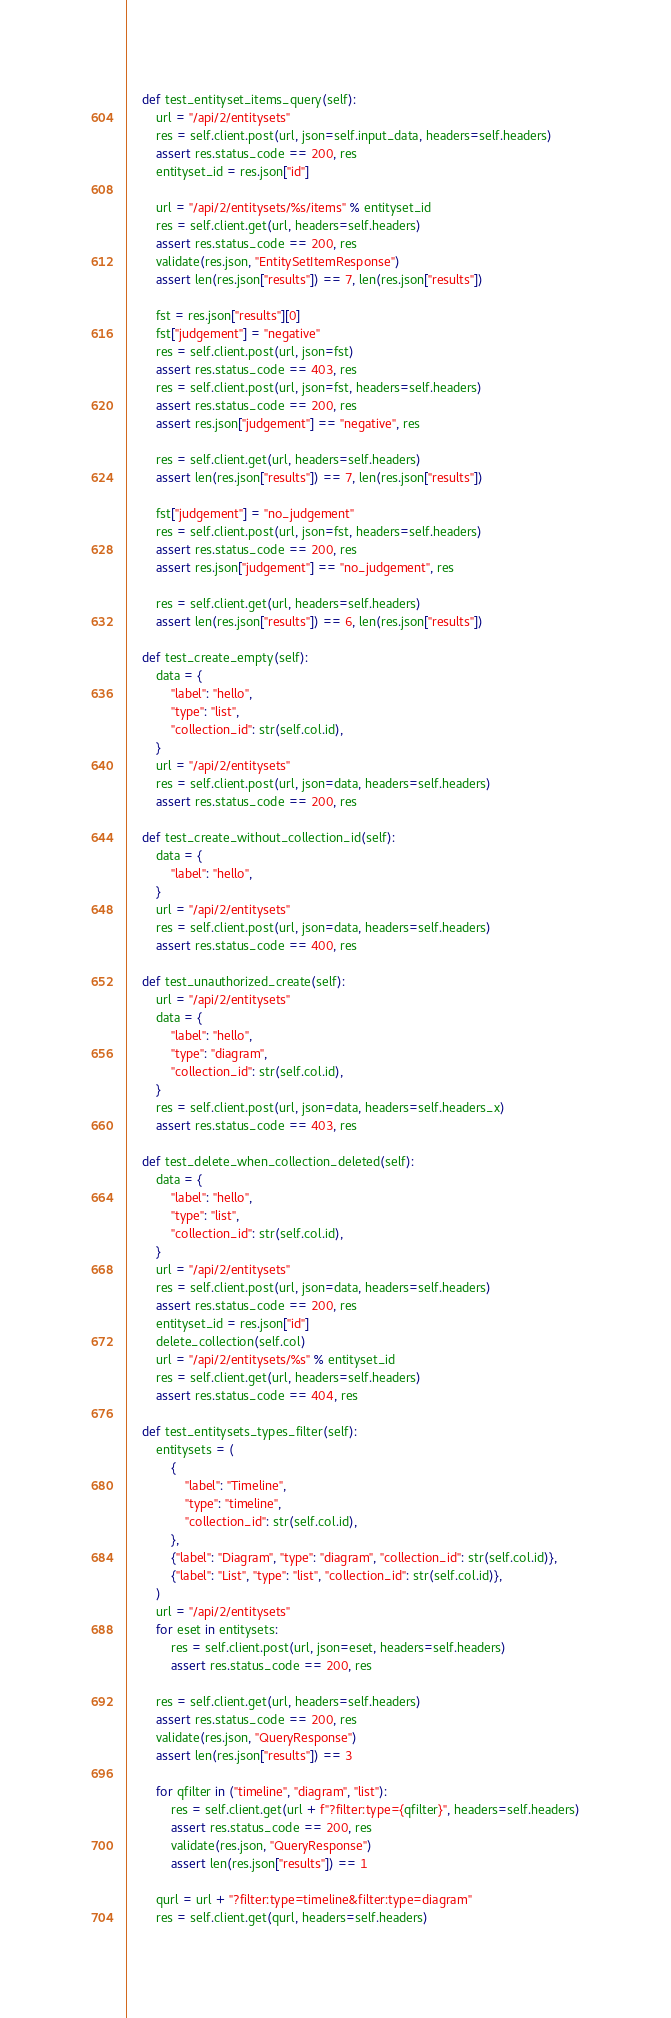<code> <loc_0><loc_0><loc_500><loc_500><_Python_>    def test_entityset_items_query(self):
        url = "/api/2/entitysets"
        res = self.client.post(url, json=self.input_data, headers=self.headers)
        assert res.status_code == 200, res
        entityset_id = res.json["id"]

        url = "/api/2/entitysets/%s/items" % entityset_id
        res = self.client.get(url, headers=self.headers)
        assert res.status_code == 200, res
        validate(res.json, "EntitySetItemResponse")
        assert len(res.json["results"]) == 7, len(res.json["results"])

        fst = res.json["results"][0]
        fst["judgement"] = "negative"
        res = self.client.post(url, json=fst)
        assert res.status_code == 403, res
        res = self.client.post(url, json=fst, headers=self.headers)
        assert res.status_code == 200, res
        assert res.json["judgement"] == "negative", res

        res = self.client.get(url, headers=self.headers)
        assert len(res.json["results"]) == 7, len(res.json["results"])

        fst["judgement"] = "no_judgement"
        res = self.client.post(url, json=fst, headers=self.headers)
        assert res.status_code == 200, res
        assert res.json["judgement"] == "no_judgement", res

        res = self.client.get(url, headers=self.headers)
        assert len(res.json["results"]) == 6, len(res.json["results"])

    def test_create_empty(self):
        data = {
            "label": "hello",
            "type": "list",
            "collection_id": str(self.col.id),
        }
        url = "/api/2/entitysets"
        res = self.client.post(url, json=data, headers=self.headers)
        assert res.status_code == 200, res

    def test_create_without_collection_id(self):
        data = {
            "label": "hello",
        }
        url = "/api/2/entitysets"
        res = self.client.post(url, json=data, headers=self.headers)
        assert res.status_code == 400, res

    def test_unauthorized_create(self):
        url = "/api/2/entitysets"
        data = {
            "label": "hello",
            "type": "diagram",
            "collection_id": str(self.col.id),
        }
        res = self.client.post(url, json=data, headers=self.headers_x)
        assert res.status_code == 403, res

    def test_delete_when_collection_deleted(self):
        data = {
            "label": "hello",
            "type": "list",
            "collection_id": str(self.col.id),
        }
        url = "/api/2/entitysets"
        res = self.client.post(url, json=data, headers=self.headers)
        assert res.status_code == 200, res
        entityset_id = res.json["id"]
        delete_collection(self.col)
        url = "/api/2/entitysets/%s" % entityset_id
        res = self.client.get(url, headers=self.headers)
        assert res.status_code == 404, res

    def test_entitysets_types_filter(self):
        entitysets = (
            {
                "label": "Timeline",
                "type": "timeline",
                "collection_id": str(self.col.id),
            },
            {"label": "Diagram", "type": "diagram", "collection_id": str(self.col.id)},
            {"label": "List", "type": "list", "collection_id": str(self.col.id)},
        )
        url = "/api/2/entitysets"
        for eset in entitysets:
            res = self.client.post(url, json=eset, headers=self.headers)
            assert res.status_code == 200, res

        res = self.client.get(url, headers=self.headers)
        assert res.status_code == 200, res
        validate(res.json, "QueryResponse")
        assert len(res.json["results"]) == 3

        for qfilter in ("timeline", "diagram", "list"):
            res = self.client.get(url + f"?filter:type={qfilter}", headers=self.headers)
            assert res.status_code == 200, res
            validate(res.json, "QueryResponse")
            assert len(res.json["results"]) == 1

        qurl = url + "?filter:type=timeline&filter:type=diagram"
        res = self.client.get(qurl, headers=self.headers)</code> 